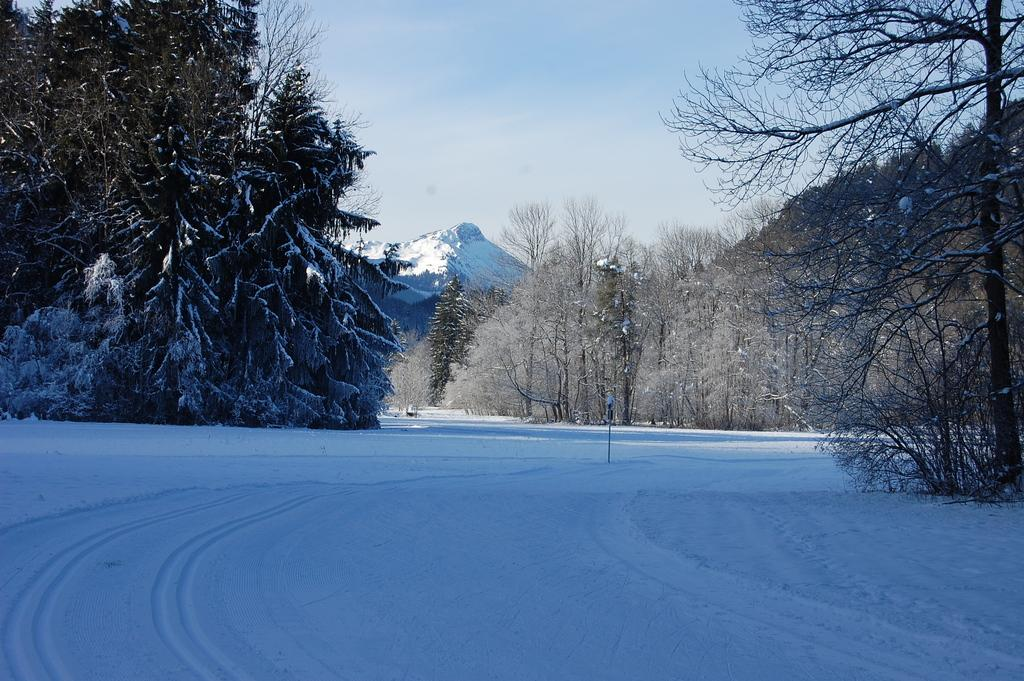What type of vegetation is present in the image? There are many trees in the image. What geographical feature can be seen in the image? There is a hill in the image. What is covering the ground at the bottom of the image? There is snow at the bottom of the image. What object is placed in the snow? There is a pole in the snow. What can be seen in the background of the image? The sky is visible in the background of the image. How many dogs are tied to the pole in the image? There are no dogs present in the image; it features trees, a hill, snow, a pole, and a visible sky. What type of bun is being used to secure the pole in the snow? There is no bun present in the image; the pole is simply placed in the snow. 